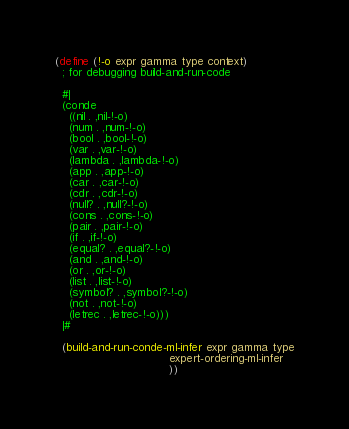Convert code to text. <code><loc_0><loc_0><loc_500><loc_500><_Scheme_>(define (!-o expr gamma type context)
  ; for debugging build-and-run-code

  #|
  (conde
    ((nil . ,nil-!-o)
    (num . ,num-!-o)
    (bool . ,bool-!-o)
    (var . ,var-!-o)
    (lambda . ,lambda-!-o)
    (app . ,app-!-o)
    (car . ,car-!-o)
    (cdr . ,cdr-!-o)
    (null? . ,null?-!-o)
    (cons . ,cons-!-o)
    (pair . ,pair-!-o)
    (if . ,if-!-o)
    (equal? . ,equal?-!-o)
    (and . ,and-!-o)
    (or . ,or-!-o)
    (list . ,list-!-o)
    (symbol? . ,symbol?-!-o)
    (not . ,not-!-o)
    (letrec . ,letrec-!-o)))
  |#
  
  (build-and-run-conde-ml-infer expr gamma type
                                expert-ordering-ml-infer
                                ))
</code> 